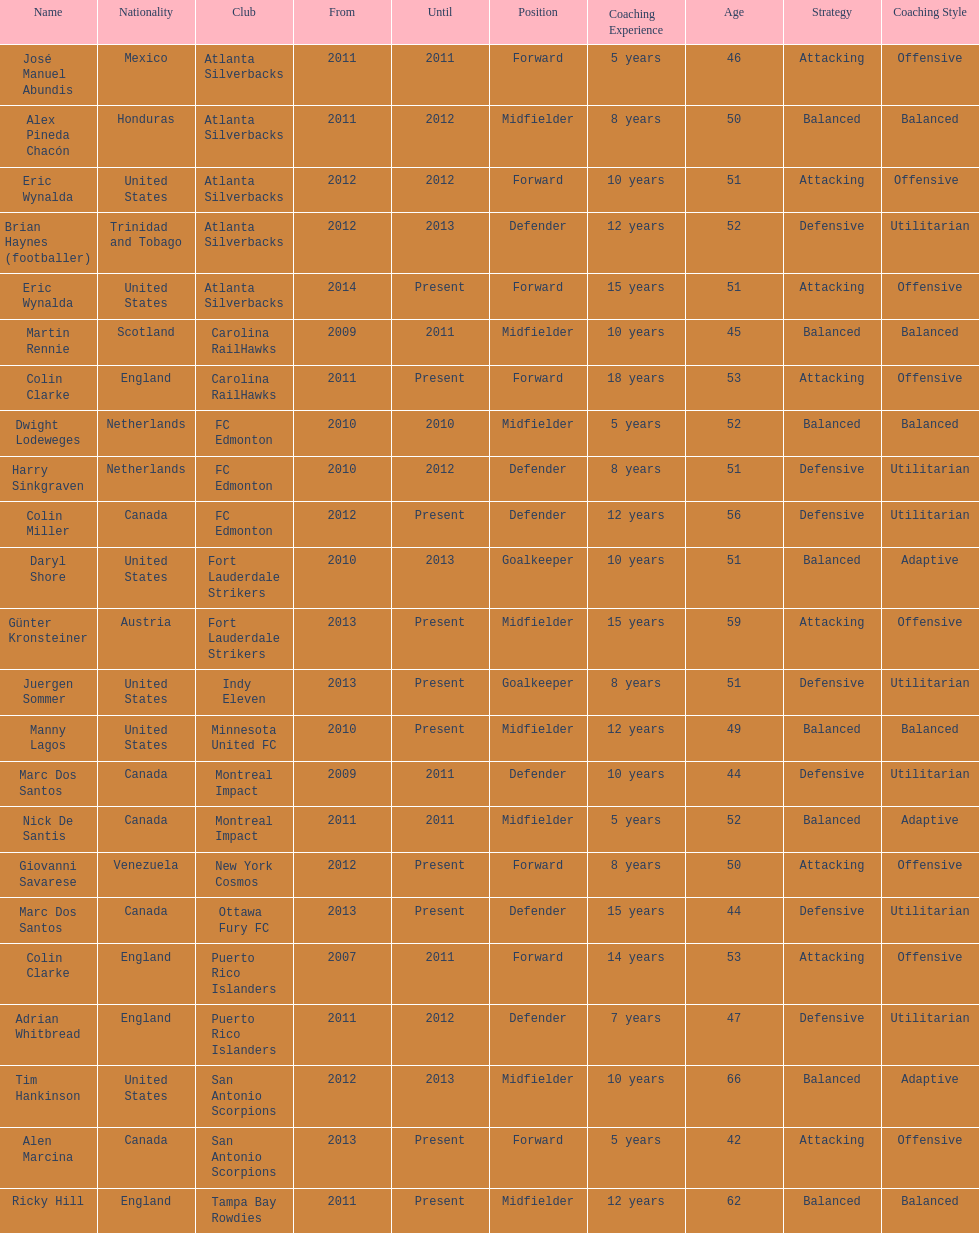Marc dos santos started as coach the same year as what other coach? Martin Rennie. 